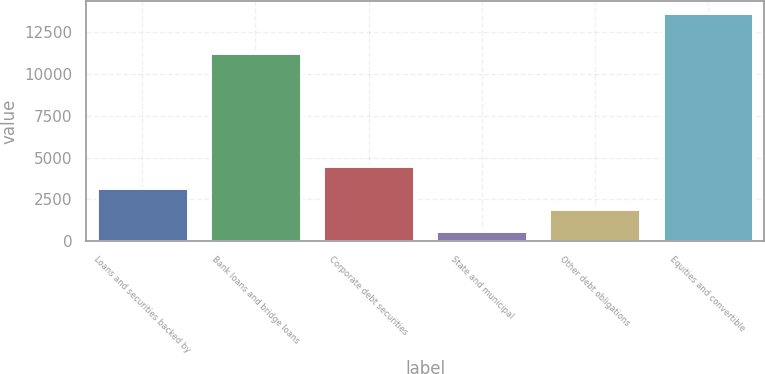<chart> <loc_0><loc_0><loc_500><loc_500><bar_chart><fcel>Loans and securities backed by<fcel>Bank loans and bridge loans<fcel>Corporate debt securities<fcel>State and municipal<fcel>Other debt obligations<fcel>Equities and convertible<nl><fcel>3212.6<fcel>11285<fcel>4519.4<fcel>599<fcel>1905.8<fcel>13667<nl></chart> 